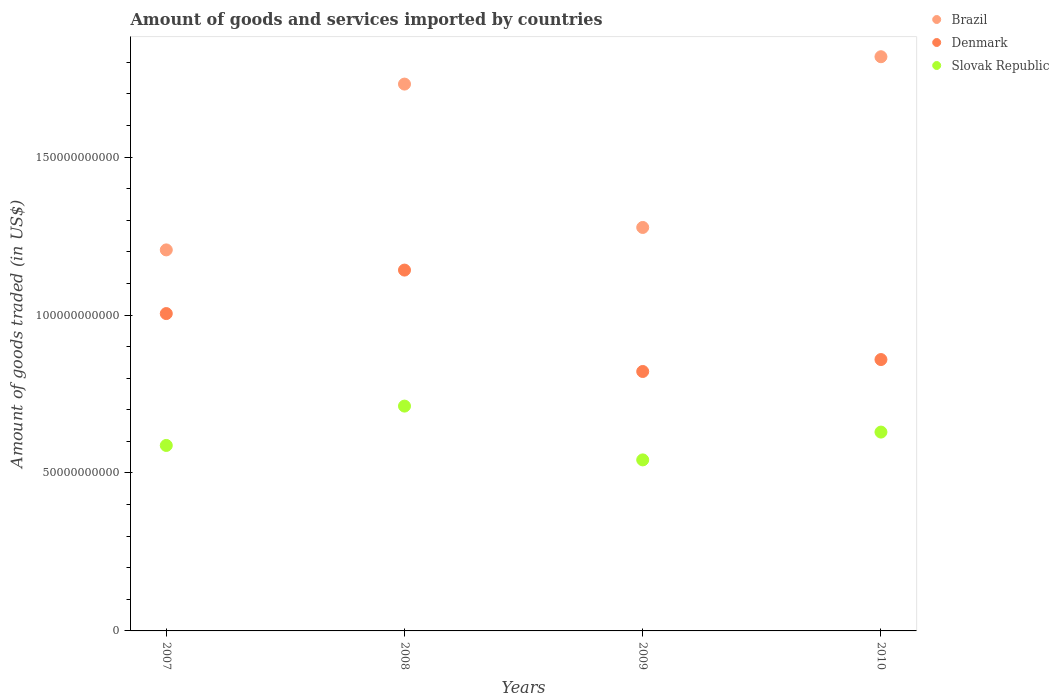Is the number of dotlines equal to the number of legend labels?
Offer a very short reply. Yes. What is the total amount of goods and services imported in Brazil in 2007?
Provide a short and direct response. 1.21e+11. Across all years, what is the maximum total amount of goods and services imported in Brazil?
Give a very brief answer. 1.82e+11. Across all years, what is the minimum total amount of goods and services imported in Denmark?
Offer a very short reply. 8.21e+1. What is the total total amount of goods and services imported in Denmark in the graph?
Ensure brevity in your answer.  3.83e+11. What is the difference between the total amount of goods and services imported in Brazil in 2009 and that in 2010?
Ensure brevity in your answer.  -5.40e+1. What is the difference between the total amount of goods and services imported in Slovak Republic in 2010 and the total amount of goods and services imported in Denmark in 2008?
Offer a very short reply. -5.13e+1. What is the average total amount of goods and services imported in Slovak Republic per year?
Offer a very short reply. 6.17e+1. In the year 2009, what is the difference between the total amount of goods and services imported in Denmark and total amount of goods and services imported in Brazil?
Offer a terse response. -4.56e+1. In how many years, is the total amount of goods and services imported in Denmark greater than 50000000000 US$?
Ensure brevity in your answer.  4. What is the ratio of the total amount of goods and services imported in Slovak Republic in 2007 to that in 2009?
Provide a short and direct response. 1.08. Is the difference between the total amount of goods and services imported in Denmark in 2007 and 2008 greater than the difference between the total amount of goods and services imported in Brazil in 2007 and 2008?
Ensure brevity in your answer.  Yes. What is the difference between the highest and the second highest total amount of goods and services imported in Brazil?
Offer a terse response. 8.66e+09. What is the difference between the highest and the lowest total amount of goods and services imported in Denmark?
Offer a very short reply. 3.21e+1. In how many years, is the total amount of goods and services imported in Brazil greater than the average total amount of goods and services imported in Brazil taken over all years?
Your answer should be compact. 2. Is the sum of the total amount of goods and services imported in Brazil in 2007 and 2008 greater than the maximum total amount of goods and services imported in Slovak Republic across all years?
Your response must be concise. Yes. Is it the case that in every year, the sum of the total amount of goods and services imported in Denmark and total amount of goods and services imported in Slovak Republic  is greater than the total amount of goods and services imported in Brazil?
Your answer should be very brief. No. Does the total amount of goods and services imported in Slovak Republic monotonically increase over the years?
Your answer should be compact. No. How many dotlines are there?
Keep it short and to the point. 3. Are the values on the major ticks of Y-axis written in scientific E-notation?
Your answer should be compact. No. Does the graph contain any zero values?
Offer a terse response. No. Does the graph contain grids?
Provide a short and direct response. No. Where does the legend appear in the graph?
Make the answer very short. Top right. What is the title of the graph?
Give a very brief answer. Amount of goods and services imported by countries. What is the label or title of the X-axis?
Offer a very short reply. Years. What is the label or title of the Y-axis?
Your response must be concise. Amount of goods traded (in US$). What is the Amount of goods traded (in US$) of Brazil in 2007?
Offer a terse response. 1.21e+11. What is the Amount of goods traded (in US$) in Denmark in 2007?
Provide a succinct answer. 1.00e+11. What is the Amount of goods traded (in US$) in Slovak Republic in 2007?
Your answer should be compact. 5.87e+1. What is the Amount of goods traded (in US$) of Brazil in 2008?
Give a very brief answer. 1.73e+11. What is the Amount of goods traded (in US$) of Denmark in 2008?
Ensure brevity in your answer.  1.14e+11. What is the Amount of goods traded (in US$) in Slovak Republic in 2008?
Ensure brevity in your answer.  7.12e+1. What is the Amount of goods traded (in US$) in Brazil in 2009?
Your answer should be very brief. 1.28e+11. What is the Amount of goods traded (in US$) in Denmark in 2009?
Your answer should be very brief. 8.21e+1. What is the Amount of goods traded (in US$) of Slovak Republic in 2009?
Provide a short and direct response. 5.41e+1. What is the Amount of goods traded (in US$) in Brazil in 2010?
Offer a very short reply. 1.82e+11. What is the Amount of goods traded (in US$) of Denmark in 2010?
Give a very brief answer. 8.59e+1. What is the Amount of goods traded (in US$) of Slovak Republic in 2010?
Ensure brevity in your answer.  6.29e+1. Across all years, what is the maximum Amount of goods traded (in US$) in Brazil?
Provide a short and direct response. 1.82e+11. Across all years, what is the maximum Amount of goods traded (in US$) in Denmark?
Your answer should be very brief. 1.14e+11. Across all years, what is the maximum Amount of goods traded (in US$) in Slovak Republic?
Your answer should be very brief. 7.12e+1. Across all years, what is the minimum Amount of goods traded (in US$) of Brazil?
Provide a succinct answer. 1.21e+11. Across all years, what is the minimum Amount of goods traded (in US$) of Denmark?
Your response must be concise. 8.21e+1. Across all years, what is the minimum Amount of goods traded (in US$) of Slovak Republic?
Ensure brevity in your answer.  5.41e+1. What is the total Amount of goods traded (in US$) in Brazil in the graph?
Provide a succinct answer. 6.03e+11. What is the total Amount of goods traded (in US$) in Denmark in the graph?
Your response must be concise. 3.83e+11. What is the total Amount of goods traded (in US$) of Slovak Republic in the graph?
Ensure brevity in your answer.  2.47e+11. What is the difference between the Amount of goods traded (in US$) of Brazil in 2007 and that in 2008?
Offer a terse response. -5.25e+1. What is the difference between the Amount of goods traded (in US$) in Denmark in 2007 and that in 2008?
Your answer should be very brief. -1.38e+1. What is the difference between the Amount of goods traded (in US$) in Slovak Republic in 2007 and that in 2008?
Ensure brevity in your answer.  -1.25e+1. What is the difference between the Amount of goods traded (in US$) of Brazil in 2007 and that in 2009?
Provide a succinct answer. -7.11e+09. What is the difference between the Amount of goods traded (in US$) of Denmark in 2007 and that in 2009?
Your answer should be very brief. 1.83e+1. What is the difference between the Amount of goods traded (in US$) in Slovak Republic in 2007 and that in 2009?
Give a very brief answer. 4.57e+09. What is the difference between the Amount of goods traded (in US$) in Brazil in 2007 and that in 2010?
Your response must be concise. -6.12e+1. What is the difference between the Amount of goods traded (in US$) in Denmark in 2007 and that in 2010?
Give a very brief answer. 1.46e+1. What is the difference between the Amount of goods traded (in US$) of Slovak Republic in 2007 and that in 2010?
Give a very brief answer. -4.23e+09. What is the difference between the Amount of goods traded (in US$) of Brazil in 2008 and that in 2009?
Make the answer very short. 4.54e+1. What is the difference between the Amount of goods traded (in US$) in Denmark in 2008 and that in 2009?
Make the answer very short. 3.21e+1. What is the difference between the Amount of goods traded (in US$) of Slovak Republic in 2008 and that in 2009?
Your response must be concise. 1.70e+1. What is the difference between the Amount of goods traded (in US$) of Brazil in 2008 and that in 2010?
Ensure brevity in your answer.  -8.66e+09. What is the difference between the Amount of goods traded (in US$) of Denmark in 2008 and that in 2010?
Offer a very short reply. 2.83e+1. What is the difference between the Amount of goods traded (in US$) of Slovak Republic in 2008 and that in 2010?
Offer a very short reply. 8.22e+09. What is the difference between the Amount of goods traded (in US$) in Brazil in 2009 and that in 2010?
Keep it short and to the point. -5.40e+1. What is the difference between the Amount of goods traded (in US$) in Denmark in 2009 and that in 2010?
Provide a succinct answer. -3.78e+09. What is the difference between the Amount of goods traded (in US$) of Slovak Republic in 2009 and that in 2010?
Keep it short and to the point. -8.80e+09. What is the difference between the Amount of goods traded (in US$) in Brazil in 2007 and the Amount of goods traded (in US$) in Denmark in 2008?
Ensure brevity in your answer.  6.39e+09. What is the difference between the Amount of goods traded (in US$) of Brazil in 2007 and the Amount of goods traded (in US$) of Slovak Republic in 2008?
Keep it short and to the point. 4.94e+1. What is the difference between the Amount of goods traded (in US$) of Denmark in 2007 and the Amount of goods traded (in US$) of Slovak Republic in 2008?
Provide a succinct answer. 2.93e+1. What is the difference between the Amount of goods traded (in US$) in Brazil in 2007 and the Amount of goods traded (in US$) in Denmark in 2009?
Your response must be concise. 3.85e+1. What is the difference between the Amount of goods traded (in US$) in Brazil in 2007 and the Amount of goods traded (in US$) in Slovak Republic in 2009?
Offer a very short reply. 6.65e+1. What is the difference between the Amount of goods traded (in US$) in Denmark in 2007 and the Amount of goods traded (in US$) in Slovak Republic in 2009?
Provide a succinct answer. 4.63e+1. What is the difference between the Amount of goods traded (in US$) of Brazil in 2007 and the Amount of goods traded (in US$) of Denmark in 2010?
Ensure brevity in your answer.  3.47e+1. What is the difference between the Amount of goods traded (in US$) in Brazil in 2007 and the Amount of goods traded (in US$) in Slovak Republic in 2010?
Your answer should be compact. 5.77e+1. What is the difference between the Amount of goods traded (in US$) of Denmark in 2007 and the Amount of goods traded (in US$) of Slovak Republic in 2010?
Provide a succinct answer. 3.75e+1. What is the difference between the Amount of goods traded (in US$) of Brazil in 2008 and the Amount of goods traded (in US$) of Denmark in 2009?
Make the answer very short. 9.10e+1. What is the difference between the Amount of goods traded (in US$) in Brazil in 2008 and the Amount of goods traded (in US$) in Slovak Republic in 2009?
Give a very brief answer. 1.19e+11. What is the difference between the Amount of goods traded (in US$) in Denmark in 2008 and the Amount of goods traded (in US$) in Slovak Republic in 2009?
Offer a very short reply. 6.01e+1. What is the difference between the Amount of goods traded (in US$) in Brazil in 2008 and the Amount of goods traded (in US$) in Denmark in 2010?
Ensure brevity in your answer.  8.72e+1. What is the difference between the Amount of goods traded (in US$) of Brazil in 2008 and the Amount of goods traded (in US$) of Slovak Republic in 2010?
Give a very brief answer. 1.10e+11. What is the difference between the Amount of goods traded (in US$) in Denmark in 2008 and the Amount of goods traded (in US$) in Slovak Republic in 2010?
Give a very brief answer. 5.13e+1. What is the difference between the Amount of goods traded (in US$) in Brazil in 2009 and the Amount of goods traded (in US$) in Denmark in 2010?
Your answer should be very brief. 4.18e+1. What is the difference between the Amount of goods traded (in US$) of Brazil in 2009 and the Amount of goods traded (in US$) of Slovak Republic in 2010?
Offer a terse response. 6.48e+1. What is the difference between the Amount of goods traded (in US$) in Denmark in 2009 and the Amount of goods traded (in US$) in Slovak Republic in 2010?
Your answer should be compact. 1.92e+1. What is the average Amount of goods traded (in US$) in Brazil per year?
Give a very brief answer. 1.51e+11. What is the average Amount of goods traded (in US$) of Denmark per year?
Provide a short and direct response. 9.57e+1. What is the average Amount of goods traded (in US$) in Slovak Republic per year?
Make the answer very short. 6.17e+1. In the year 2007, what is the difference between the Amount of goods traded (in US$) in Brazil and Amount of goods traded (in US$) in Denmark?
Offer a terse response. 2.02e+1. In the year 2007, what is the difference between the Amount of goods traded (in US$) of Brazil and Amount of goods traded (in US$) of Slovak Republic?
Make the answer very short. 6.19e+1. In the year 2007, what is the difference between the Amount of goods traded (in US$) in Denmark and Amount of goods traded (in US$) in Slovak Republic?
Provide a succinct answer. 4.17e+1. In the year 2008, what is the difference between the Amount of goods traded (in US$) of Brazil and Amount of goods traded (in US$) of Denmark?
Offer a terse response. 5.89e+1. In the year 2008, what is the difference between the Amount of goods traded (in US$) in Brazil and Amount of goods traded (in US$) in Slovak Republic?
Give a very brief answer. 1.02e+11. In the year 2008, what is the difference between the Amount of goods traded (in US$) of Denmark and Amount of goods traded (in US$) of Slovak Republic?
Make the answer very short. 4.31e+1. In the year 2009, what is the difference between the Amount of goods traded (in US$) of Brazil and Amount of goods traded (in US$) of Denmark?
Provide a succinct answer. 4.56e+1. In the year 2009, what is the difference between the Amount of goods traded (in US$) in Brazil and Amount of goods traded (in US$) in Slovak Republic?
Provide a short and direct response. 7.36e+1. In the year 2009, what is the difference between the Amount of goods traded (in US$) of Denmark and Amount of goods traded (in US$) of Slovak Republic?
Ensure brevity in your answer.  2.80e+1. In the year 2010, what is the difference between the Amount of goods traded (in US$) of Brazil and Amount of goods traded (in US$) of Denmark?
Offer a terse response. 9.59e+1. In the year 2010, what is the difference between the Amount of goods traded (in US$) of Brazil and Amount of goods traded (in US$) of Slovak Republic?
Give a very brief answer. 1.19e+11. In the year 2010, what is the difference between the Amount of goods traded (in US$) in Denmark and Amount of goods traded (in US$) in Slovak Republic?
Offer a terse response. 2.30e+1. What is the ratio of the Amount of goods traded (in US$) in Brazil in 2007 to that in 2008?
Offer a terse response. 0.7. What is the ratio of the Amount of goods traded (in US$) in Denmark in 2007 to that in 2008?
Provide a short and direct response. 0.88. What is the ratio of the Amount of goods traded (in US$) of Slovak Republic in 2007 to that in 2008?
Keep it short and to the point. 0.82. What is the ratio of the Amount of goods traded (in US$) of Denmark in 2007 to that in 2009?
Offer a terse response. 1.22. What is the ratio of the Amount of goods traded (in US$) of Slovak Republic in 2007 to that in 2009?
Offer a very short reply. 1.08. What is the ratio of the Amount of goods traded (in US$) of Brazil in 2007 to that in 2010?
Your answer should be very brief. 0.66. What is the ratio of the Amount of goods traded (in US$) in Denmark in 2007 to that in 2010?
Your response must be concise. 1.17. What is the ratio of the Amount of goods traded (in US$) of Slovak Republic in 2007 to that in 2010?
Your response must be concise. 0.93. What is the ratio of the Amount of goods traded (in US$) in Brazil in 2008 to that in 2009?
Keep it short and to the point. 1.36. What is the ratio of the Amount of goods traded (in US$) in Denmark in 2008 to that in 2009?
Offer a very short reply. 1.39. What is the ratio of the Amount of goods traded (in US$) of Slovak Republic in 2008 to that in 2009?
Offer a terse response. 1.31. What is the ratio of the Amount of goods traded (in US$) in Brazil in 2008 to that in 2010?
Offer a terse response. 0.95. What is the ratio of the Amount of goods traded (in US$) of Denmark in 2008 to that in 2010?
Ensure brevity in your answer.  1.33. What is the ratio of the Amount of goods traded (in US$) of Slovak Republic in 2008 to that in 2010?
Provide a succinct answer. 1.13. What is the ratio of the Amount of goods traded (in US$) of Brazil in 2009 to that in 2010?
Offer a terse response. 0.7. What is the ratio of the Amount of goods traded (in US$) of Denmark in 2009 to that in 2010?
Ensure brevity in your answer.  0.96. What is the ratio of the Amount of goods traded (in US$) in Slovak Republic in 2009 to that in 2010?
Your response must be concise. 0.86. What is the difference between the highest and the second highest Amount of goods traded (in US$) in Brazil?
Your answer should be compact. 8.66e+09. What is the difference between the highest and the second highest Amount of goods traded (in US$) of Denmark?
Offer a terse response. 1.38e+1. What is the difference between the highest and the second highest Amount of goods traded (in US$) of Slovak Republic?
Offer a terse response. 8.22e+09. What is the difference between the highest and the lowest Amount of goods traded (in US$) of Brazil?
Make the answer very short. 6.12e+1. What is the difference between the highest and the lowest Amount of goods traded (in US$) in Denmark?
Offer a very short reply. 3.21e+1. What is the difference between the highest and the lowest Amount of goods traded (in US$) in Slovak Republic?
Ensure brevity in your answer.  1.70e+1. 